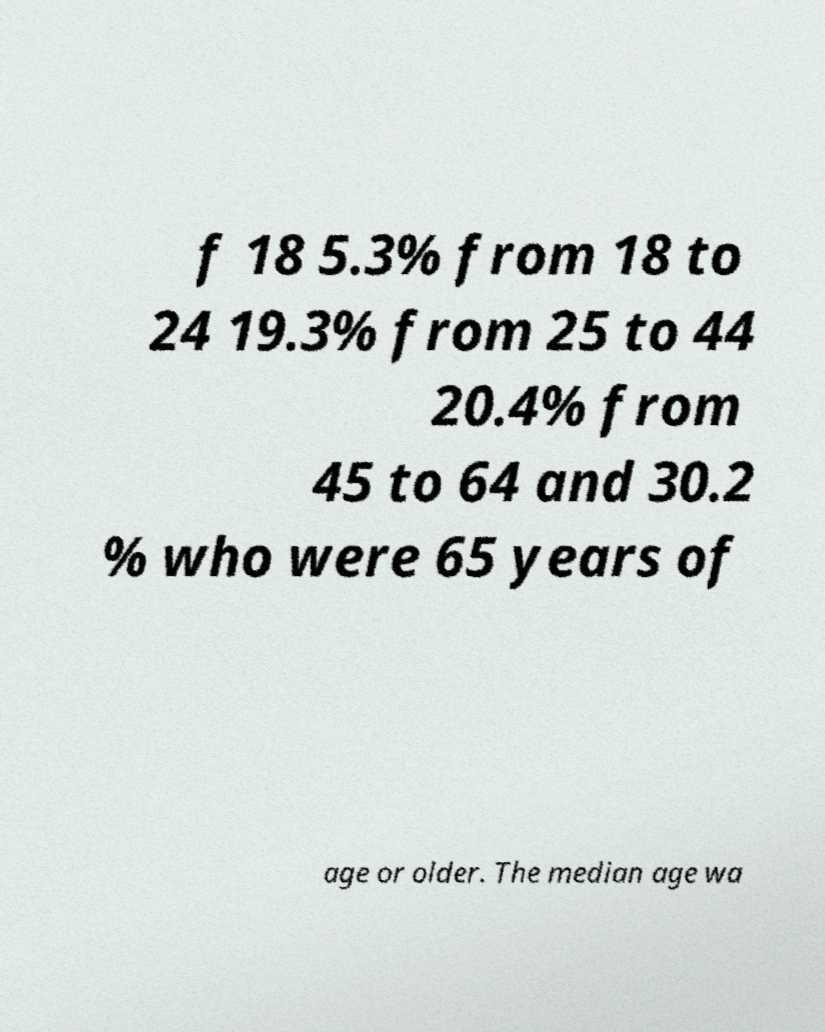I need the written content from this picture converted into text. Can you do that? f 18 5.3% from 18 to 24 19.3% from 25 to 44 20.4% from 45 to 64 and 30.2 % who were 65 years of age or older. The median age wa 